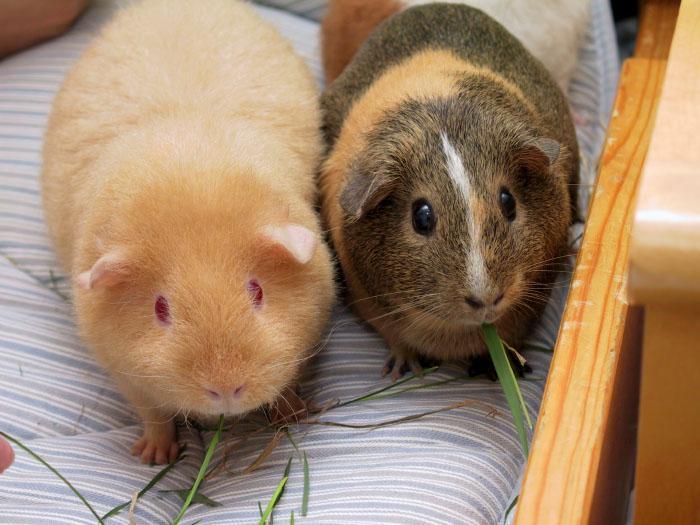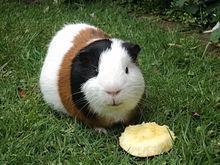The first image is the image on the left, the second image is the image on the right. For the images shown, is this caption "An image shows a pet rodent dressed in a uniform vest costume." true? Answer yes or no. No. The first image is the image on the left, the second image is the image on the right. For the images displayed, is the sentence "Three gerbils are in a grassy outdoor area, one alone wearing a costume, while two of different colors are together." factually correct? Answer yes or no. No. 